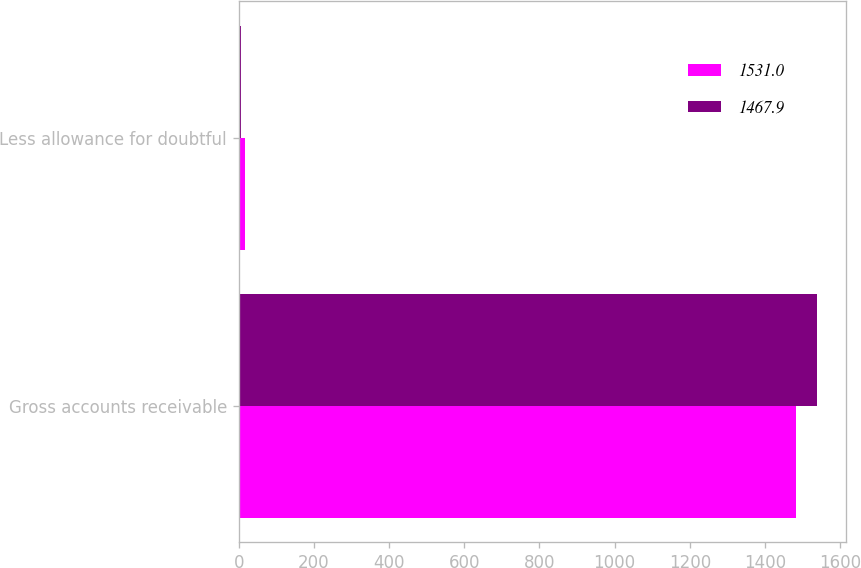<chart> <loc_0><loc_0><loc_500><loc_500><stacked_bar_chart><ecel><fcel>Gross accounts receivable<fcel>Less allowance for doubtful<nl><fcel>1531<fcel>1483.6<fcel>15.7<nl><fcel>1467.9<fcel>1537.2<fcel>6.2<nl></chart> 